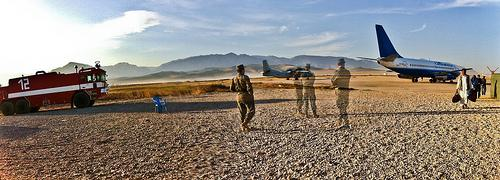Describe the type and color of the chair in the image, and where it is positioned. There is a light blue plastic chair resting on the ground. Assess the overall sentiment of the image, based on the activity taking place. The image has a neutral sentiment, possibly leaning towards anticipation and excitement, as people are seen walking to the airplane and there's activity on the ground. Count how many men are carrying bags or suitcases, and provide details about their appearance. There are two men carrying bags - one is wearing white and carrying black suitcases, and the other is carrying a black bag. How many different types of vehicles or aircraft can be seen in the image? There are three different types: a red and white truck, a blue and white airplane, and a red vehicle with the number 12 on it. Explain the unique feature of the group of men in jumpsuits. The group of men in jumpsuits appear translucent, as if they are ghost-like or see-through. Identify the color and number on the vehicle in the image. The vehicle is red and has the number 12 on it. What could potentially be the purpose of the people following the man? The people might be following the man as he guides them to their destination, like boarding the airplane or attending some event. What type of landscape is depicted in the image? A dry flat plains area with mountains in the distance. What type of aircraft is visible in the image, and what are its noticeable colors? A light-colored jet plane is visible, with blue and white markings on its body. Is there an alien inside the see-through plane? It's not every day that an outer space visitor graces our planet. The instruction is misleading because there is no mention of an alien in the object list, and the assumption of an extraterrestrial being inside the plane adds an element that does not exist in the picture. Can you identify a karaoke machine placed between the group of people walking? It seems like they are about to start an impromptu singing session. The instruction is misleading because there is no karaoke machine mentioned in the image's object list, and it fabricates a backstory about an activity that is not evident in the picture. Is it possible to spot a pink balloon hovering above the mountains in the background? It appears that the wind has blown it from a nearby party. No, it's not mentioned in the image. Do you notice a swarm of butterflies flying around the green tent? It's quite rare to have a butterfly outbreak in such a location. The instruction is misleading because there is no mention of butterflies in the image's object list, and it also suggests an unlikely event happening in the picture. Can you find the purple unicorn standing next to the blue chair? It's pretty unusual to have an unseen purple unicorn in the picture. The instruction is misleading because there is no mention of a purple unicorn in the image's object list, and unicorns are mythical creatures not real ones. Try to locate a yellow submarine emerging from the ground near the firetruck. It's quite peculiar to see a yellow submarine in this atmosphere. The instruction is misleading because there is no mention of a yellow submarine in the image's object list, and submarines are marine vehicles commonly not found on land. 